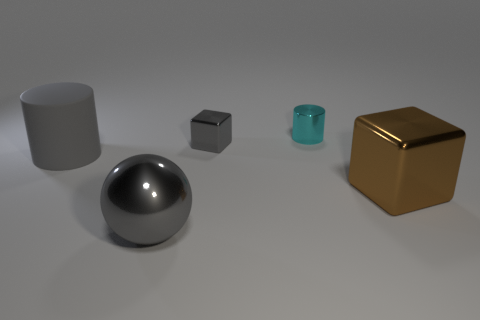Add 1 big brown objects. How many objects exist? 6 Subtract all cylinders. How many objects are left? 3 Add 4 gray metal balls. How many gray metal balls are left? 5 Add 2 tiny balls. How many tiny balls exist? 2 Subtract 0 red cylinders. How many objects are left? 5 Subtract all yellow matte cylinders. Subtract all big brown blocks. How many objects are left? 4 